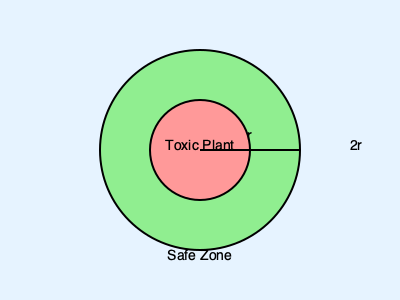In your pet-friendly garden, you want to plant a potentially harmful plant while ensuring the safety of your pets. The diagram shows a toxic plant with a safe zone around it. If the radius of the toxic plant's spread is $r$ meters, and you want to maintain a safe distance that is twice the plant's spread, what is the total area of the safe zone in square meters? To calculate the total area of the safe zone, we need to follow these steps:

1. Identify the radius of the safe zone:
   - The safe distance is twice the plant's spread, so the radius of the safe zone is $2r$.

2. Calculate the area of the entire circle (safe zone + toxic plant area):
   - Area of a circle is given by the formula $A = \pi r^2$
   - For the safe zone, the radius is $2r$
   - Area of safe zone circle = $\pi (2r)^2 = 4\pi r^2$

3. Calculate the area of the toxic plant:
   - The radius of the toxic plant is $r$
   - Area of toxic plant = $\pi r^2$

4. Calculate the area of the safe zone by subtracting the toxic plant area from the total area:
   - Safe zone area = Total area - Toxic plant area
   - Safe zone area = $4\pi r^2 - \pi r^2 = 3\pi r^2$

Therefore, the total area of the safe zone is $3\pi r^2$ square meters.
Answer: $3\pi r^2$ sq m 